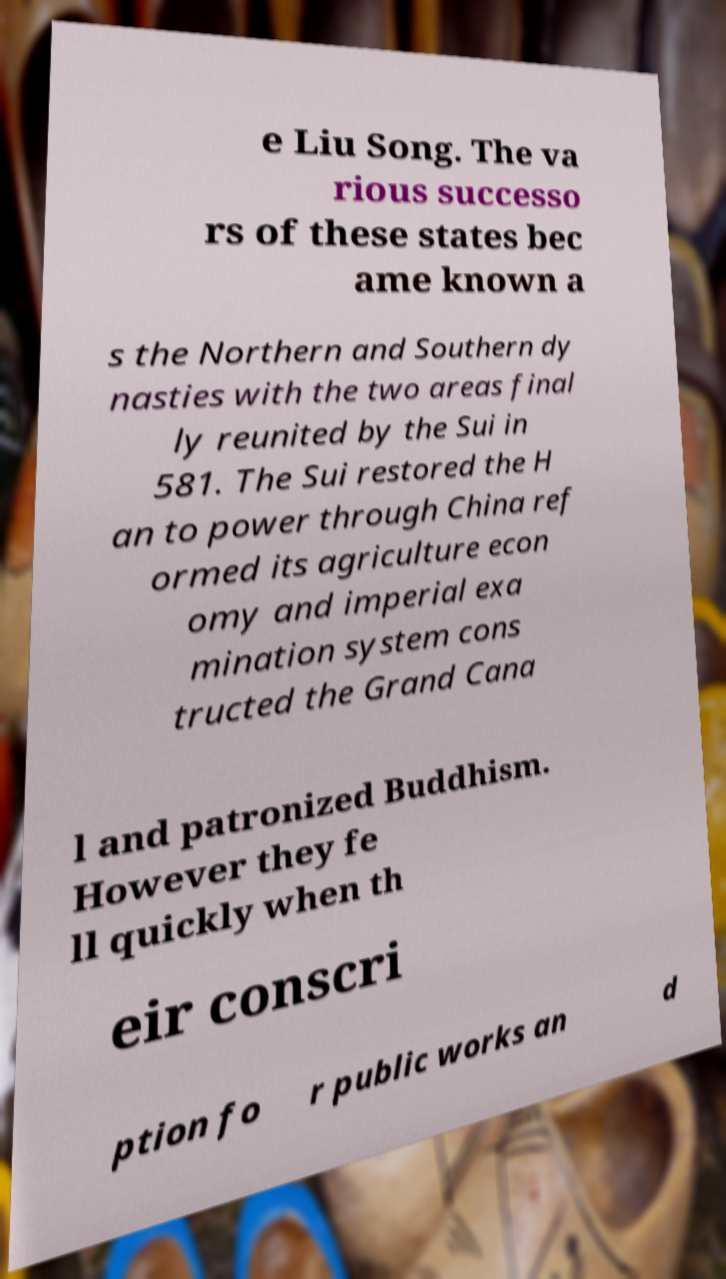Please identify and transcribe the text found in this image. e Liu Song. The va rious successo rs of these states bec ame known a s the Northern and Southern dy nasties with the two areas final ly reunited by the Sui in 581. The Sui restored the H an to power through China ref ormed its agriculture econ omy and imperial exa mination system cons tructed the Grand Cana l and patronized Buddhism. However they fe ll quickly when th eir conscri ption fo r public works an d 